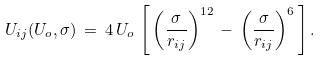Convert formula to latex. <formula><loc_0><loc_0><loc_500><loc_500>U _ { i j } ( U _ { o } , \sigma ) \, = \, 4 \, U _ { o } \, \left [ \, \left ( \frac { \sigma } { r _ { i j } } \right ) ^ { 1 2 } \, - \, \left ( \frac { \sigma } { r _ { i j } } \right ) ^ { 6 } \, \right ] .</formula> 